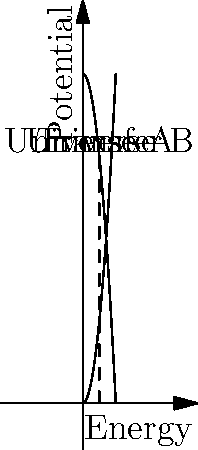In a fictional multiverse, two self-contained universes (A and B) are modeled as a closed system. Initially, Universe A has 100 units of potential energy, while Universe B has 0. As energy transfers between the universes, their potential energies change according to the functions $P_A(x) = 100 - x^2$ and $P_B(x) = x^2$, where x is the amount of energy transferred. At what point of energy transfer will the two universes have equal potential energy? To solve this problem, we need to follow these steps:

1) The potential energies of the universes are given by:
   Universe A: $P_A(x) = 100 - x^2$
   Universe B: $P_B(x) = x^2$

2) We want to find the point where these potentials are equal:
   $P_A(x) = P_B(x)$

3) Substituting the functions:
   $100 - x^2 = x^2$

4) Solving the equation:
   $100 = 2x^2$
   $50 = x^2$
   $x = \sqrt{50} \approx 7.071$

5) To verify, we can check the potential energy of each universe at this point:
   $P_A(7.071) = 100 - (7.071)^2 = 50$
   $P_B(7.071) = (7.071)^2 = 50$

6) The total energy of the system remains constant at 100 units, confirming the conservation of energy in this closed system.
Answer: $\sqrt{50}$ units of energy transferred 